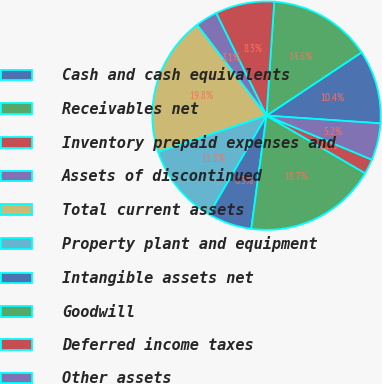Convert chart to OTSL. <chart><loc_0><loc_0><loc_500><loc_500><pie_chart><fcel>Cash and cash equivalents<fcel>Receivables net<fcel>Inventory prepaid expenses and<fcel>Assets of discontinued<fcel>Total current assets<fcel>Property plant and equipment<fcel>Intangible assets net<fcel>Goodwill<fcel>Deferred income taxes<fcel>Other assets<nl><fcel>10.42%<fcel>14.57%<fcel>8.34%<fcel>3.14%<fcel>19.76%<fcel>11.45%<fcel>6.26%<fcel>18.72%<fcel>2.11%<fcel>5.22%<nl></chart> 